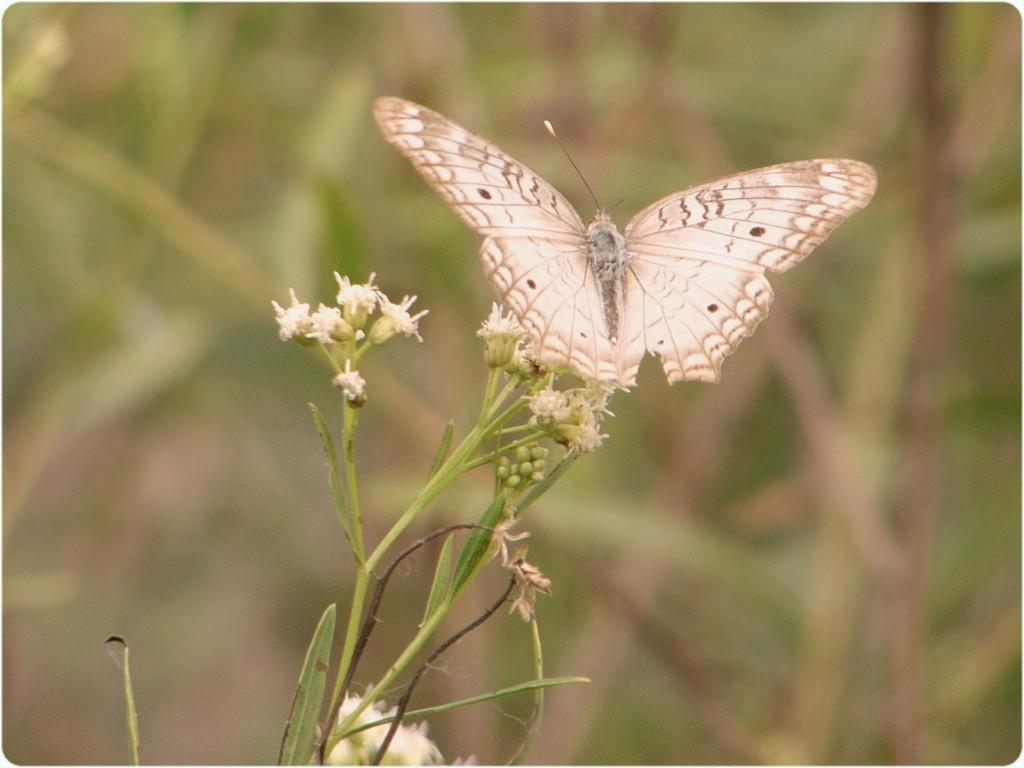What is present in the image? There is a butterfly in the image. Where is the butterfly located? The butterfly is on the flower of a plant. What type of wood is the butterfly using to balance on the flower? The butterfly is not using any wood to balance on the flower, as it is a butterfly on a flower and not a circus act. 